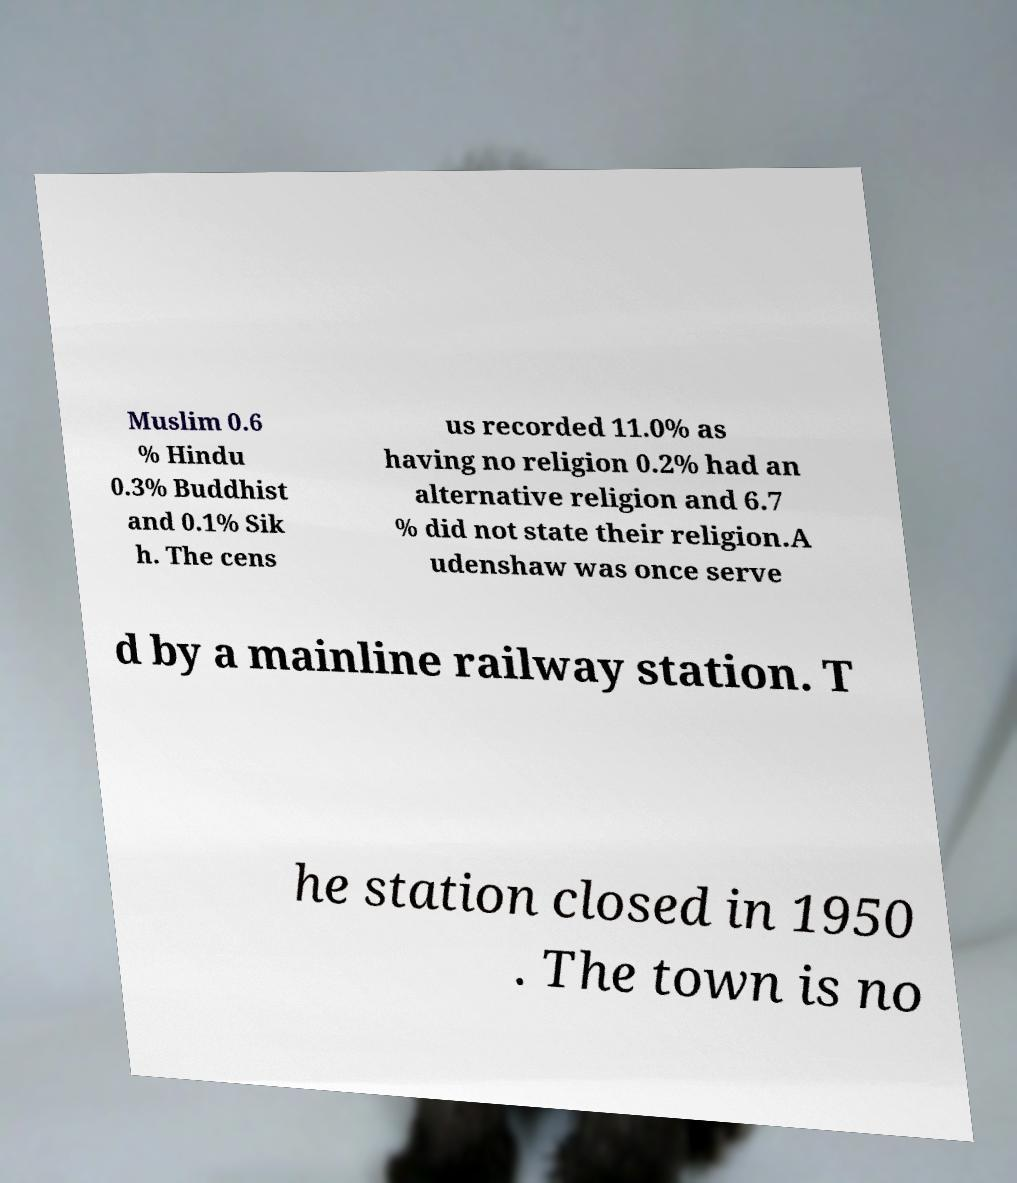Can you accurately transcribe the text from the provided image for me? Muslim 0.6 % Hindu 0.3% Buddhist and 0.1% Sik h. The cens us recorded 11.0% as having no religion 0.2% had an alternative religion and 6.7 % did not state their religion.A udenshaw was once serve d by a mainline railway station. T he station closed in 1950 . The town is no 